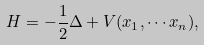<formula> <loc_0><loc_0><loc_500><loc_500>H = - \frac { 1 } { 2 } \Delta + V ( x _ { 1 } , \cdots x _ { n } ) ,</formula> 